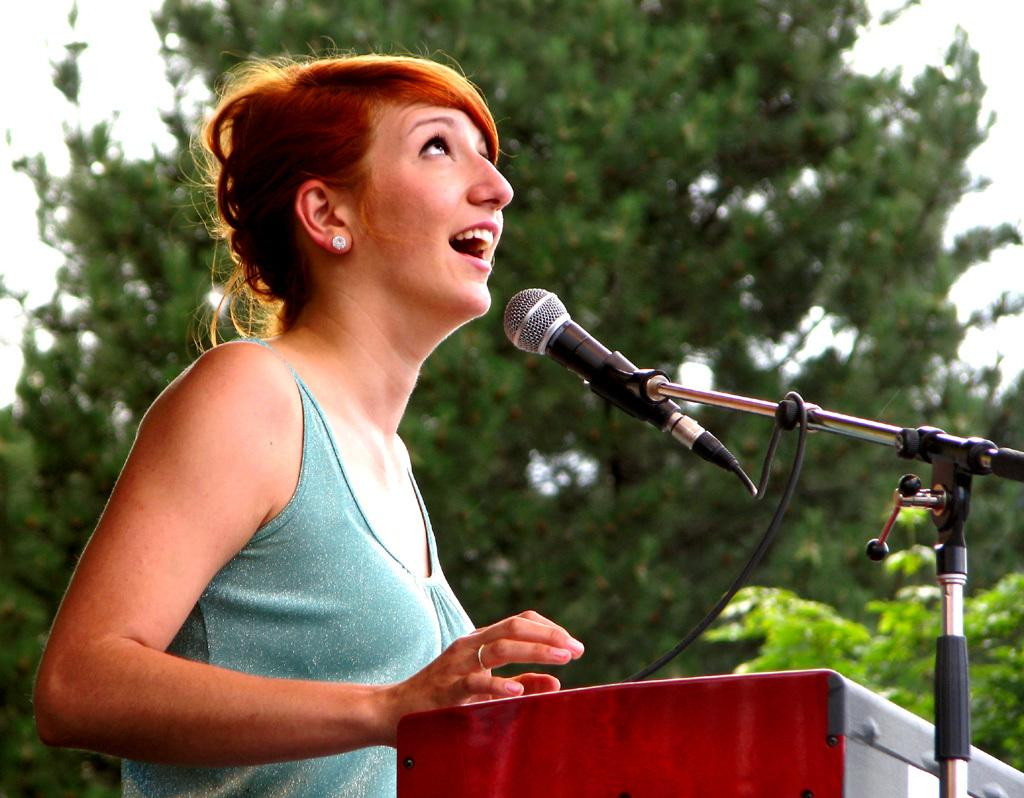What is the woman in the image doing? The woman is standing at a podium in the image. What is the woman using to amplify her voice? There is a microphone with a stand on the right side of the image. What can be seen in the background of the image? Trees and the sky are visible in the background of the image. What class is the woman teaching in the image? There is no indication of a class or teaching in the image; it simply shows a woman standing at a podium with a microphone. 